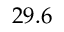<formula> <loc_0><loc_0><loc_500><loc_500>2 9 . 6</formula> 